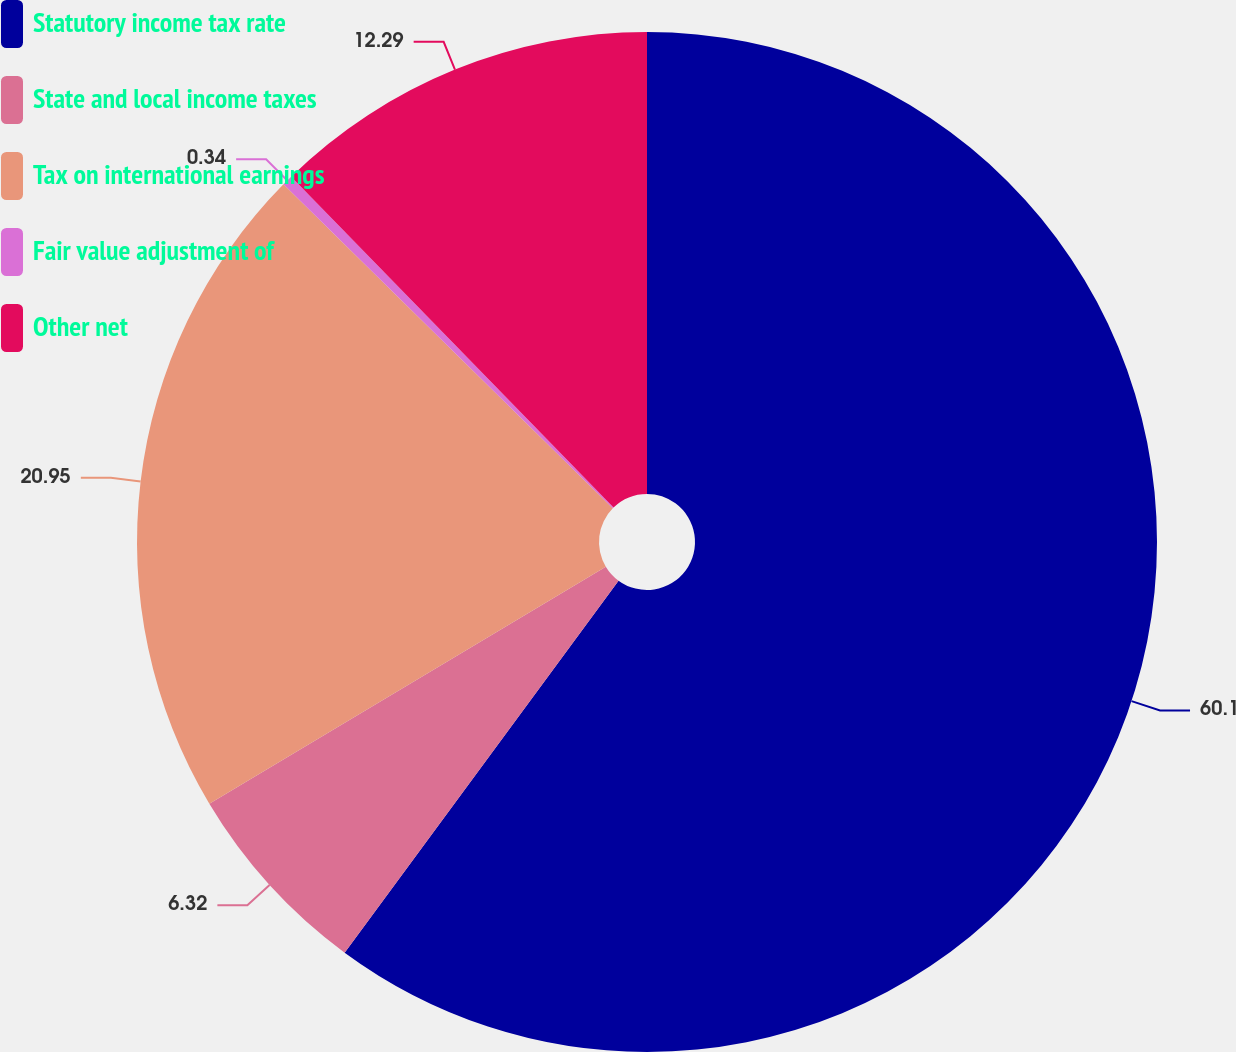Convert chart to OTSL. <chart><loc_0><loc_0><loc_500><loc_500><pie_chart><fcel>Statutory income tax rate<fcel>State and local income taxes<fcel>Tax on international earnings<fcel>Fair value adjustment of<fcel>Other net<nl><fcel>60.1%<fcel>6.32%<fcel>20.95%<fcel>0.34%<fcel>12.29%<nl></chart> 